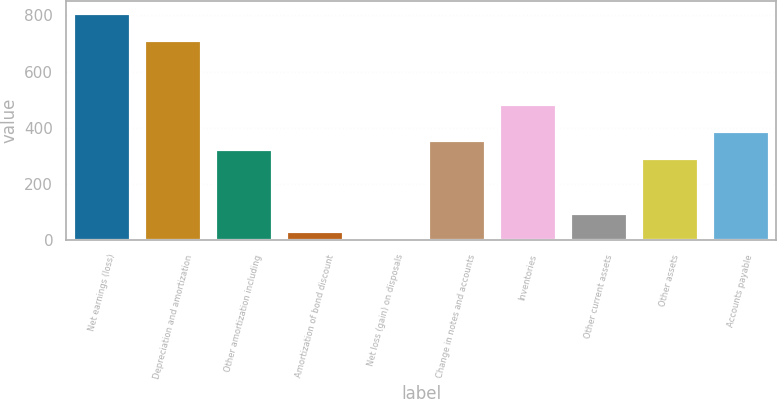<chart> <loc_0><loc_0><loc_500><loc_500><bar_chart><fcel>Net earnings (loss)<fcel>Depreciation and amortization<fcel>Other amortization including<fcel>Amortization of bond discount<fcel>Net loss (gain) on disposals<fcel>Change in notes and accounts<fcel>Inventories<fcel>Other current assets<fcel>Other assets<fcel>Accounts payable<nl><fcel>809.6<fcel>712.46<fcel>323.9<fcel>32.48<fcel>0.1<fcel>356.28<fcel>485.8<fcel>97.24<fcel>291.52<fcel>388.66<nl></chart> 